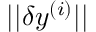Convert formula to latex. <formula><loc_0><loc_0><loc_500><loc_500>| | \delta y ^ { ( i ) } | |</formula> 